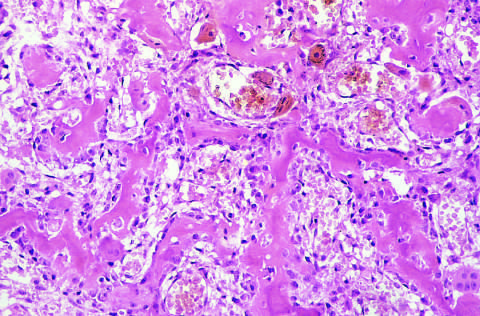what is osteoid osteoma composed of?
Answer the question using a single word or phrase. Haphazardly interconnecting trabeculae of woven bone that are rimmed by prominent osteoblasts 